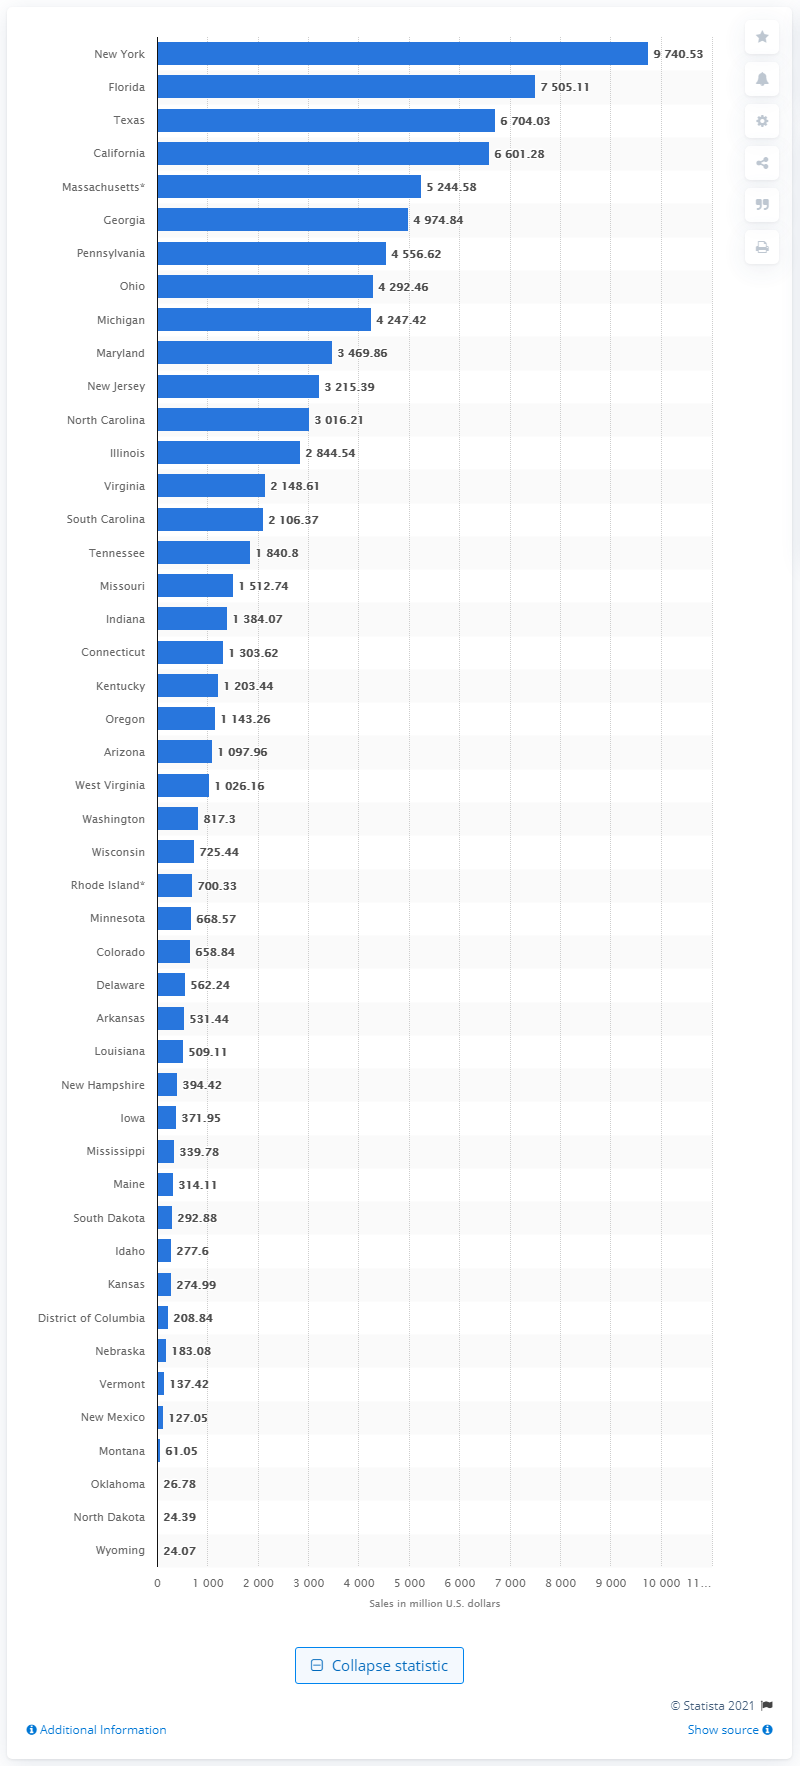Identify some key points in this picture. In 2020, the total sales of lottery tickets in Texas were approximately $9,740.53. In 2020, the state of New York generated approximately $9,740.53 in lottery sales. In 2020, the state with the largest lottery sales was New York. 